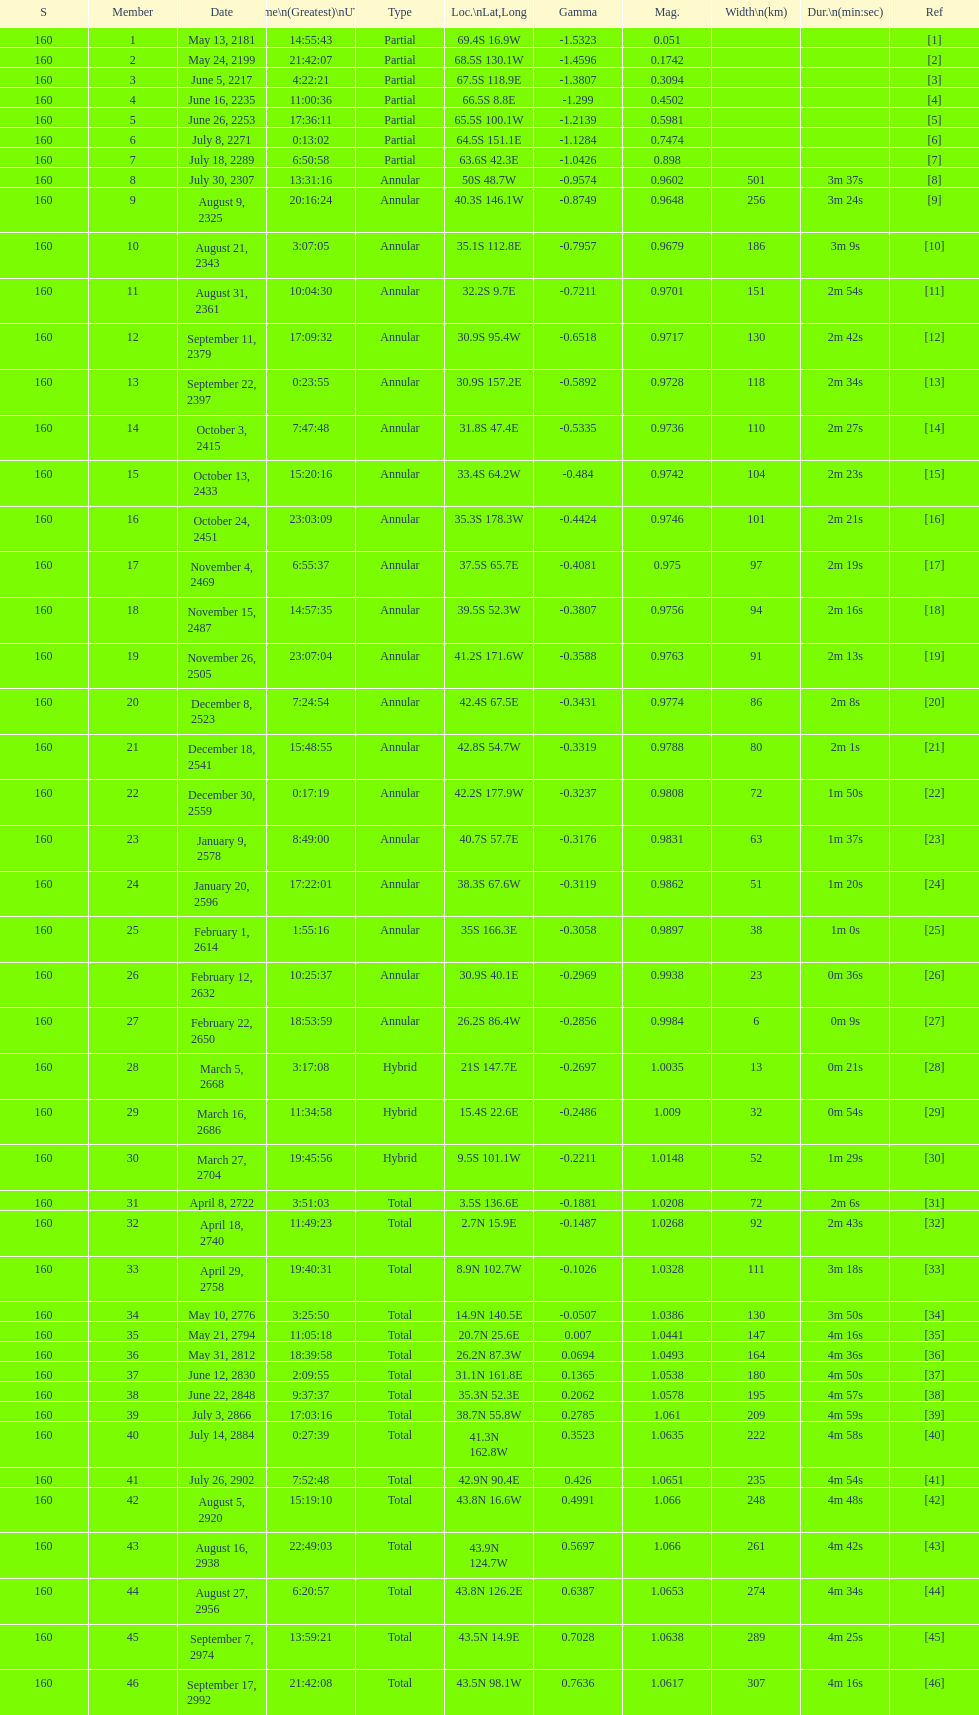What is the previous time for the saros on october 3, 2415? 7:47:48. 